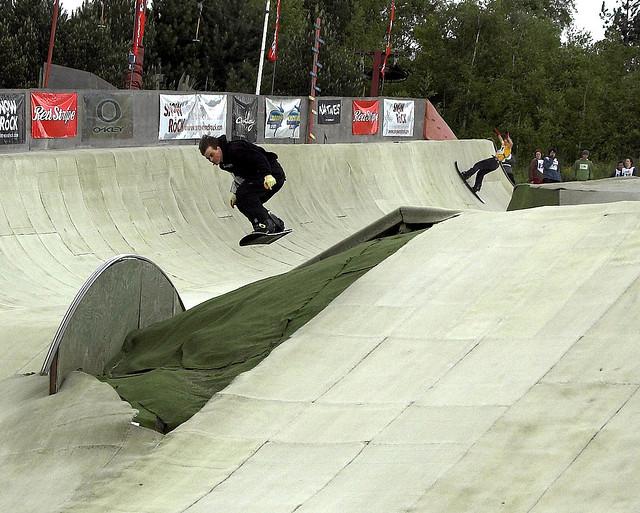What are the men riding?
Write a very short answer. Skateboards. What is the man wearing?
Give a very brief answer. Clothes. Where is his head protection?
Concise answer only. At home. 